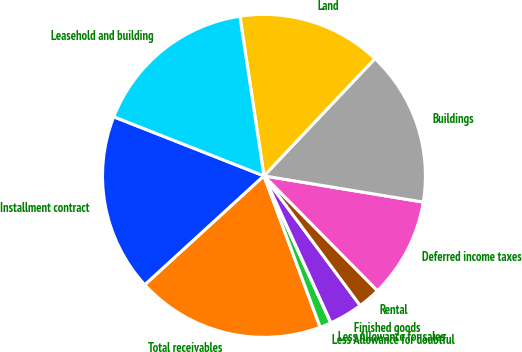Convert chart. <chart><loc_0><loc_0><loc_500><loc_500><pie_chart><fcel>Installment contract<fcel>Total receivables<fcel>Less Allowance for doubtful<fcel>Less Allowance for sales<fcel>Finished goods<fcel>Rental<fcel>Deferred income taxes<fcel>Buildings<fcel>Land<fcel>Leasehold and building<nl><fcel>17.76%<fcel>18.87%<fcel>1.13%<fcel>0.02%<fcel>3.35%<fcel>2.24%<fcel>10.0%<fcel>15.54%<fcel>14.44%<fcel>16.65%<nl></chart> 